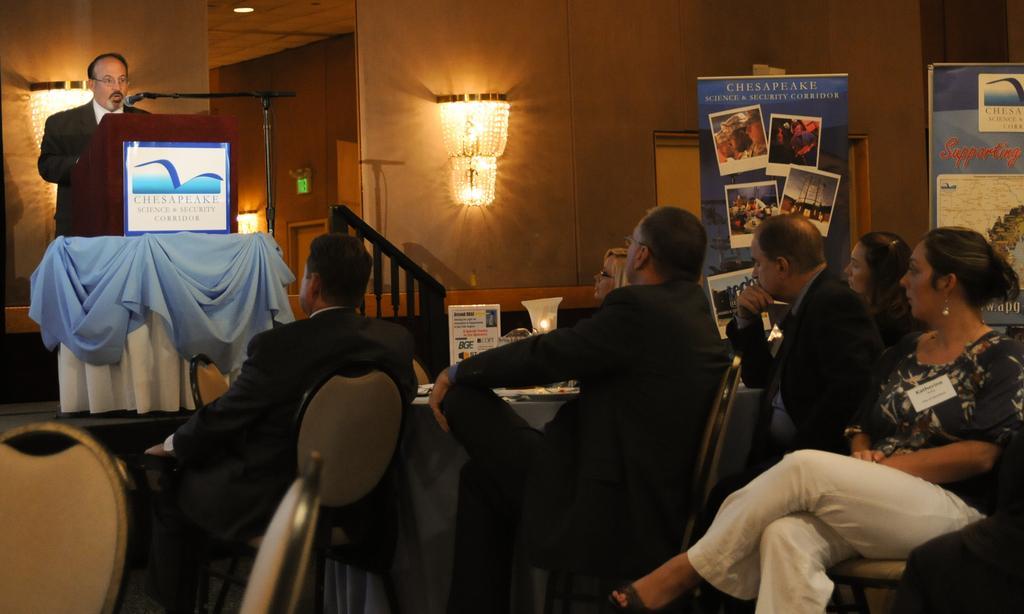Can you describe this image briefly? To the right corner of the image there is a lady with black top and white pant is sitting. Behind her there are posters. Beside her there are few men sitting on the chair. In front of the there is a table with cards and lamp on it. In front of them there is a stage with podium on it. And to the podium there is a white and blue color cloth and also there is a mic. Behind the podium there is a man standing. In the background there is a wall with lights and also there is a room. 